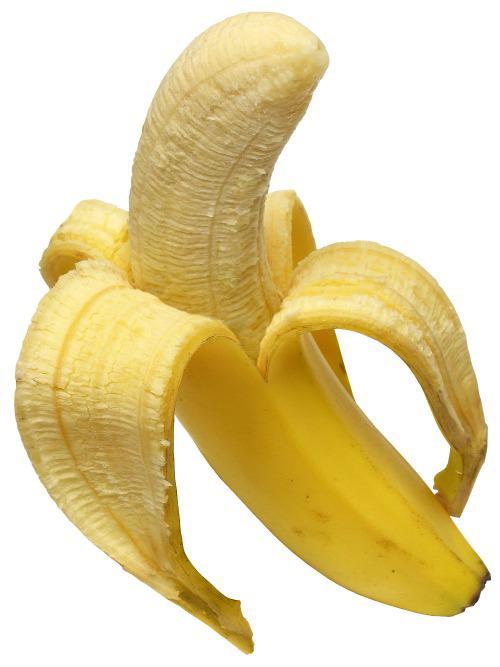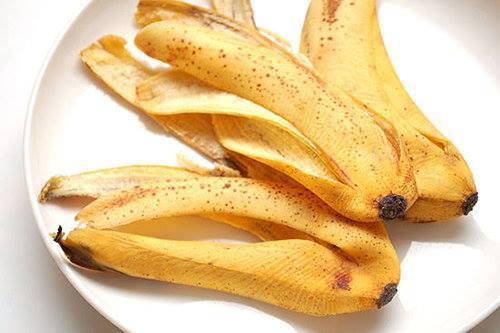The first image is the image on the left, the second image is the image on the right. For the images shown, is this caption "Atleast one photo in the pair is a single half peeled banana" true? Answer yes or no. Yes. 